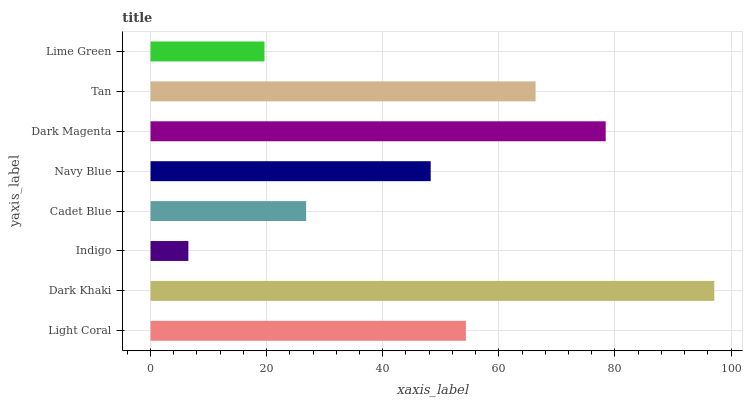Is Indigo the minimum?
Answer yes or no. Yes. Is Dark Khaki the maximum?
Answer yes or no. Yes. Is Dark Khaki the minimum?
Answer yes or no. No. Is Indigo the maximum?
Answer yes or no. No. Is Dark Khaki greater than Indigo?
Answer yes or no. Yes. Is Indigo less than Dark Khaki?
Answer yes or no. Yes. Is Indigo greater than Dark Khaki?
Answer yes or no. No. Is Dark Khaki less than Indigo?
Answer yes or no. No. Is Light Coral the high median?
Answer yes or no. Yes. Is Navy Blue the low median?
Answer yes or no. Yes. Is Tan the high median?
Answer yes or no. No. Is Light Coral the low median?
Answer yes or no. No. 